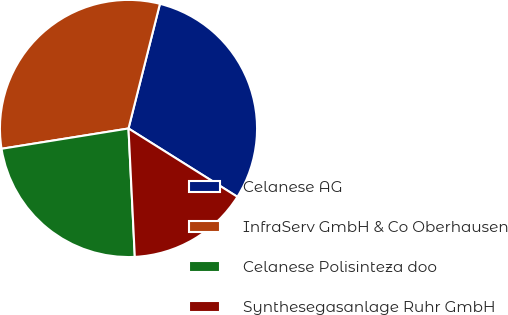Convert chart. <chart><loc_0><loc_0><loc_500><loc_500><pie_chart><fcel>Celanese AG<fcel>InfraServ GmbH & Co Oberhausen<fcel>Celanese Polisinteza doo<fcel>Synthesegasanlage Ruhr GmbH<nl><fcel>29.99%<fcel>31.46%<fcel>23.26%<fcel>15.3%<nl></chart> 